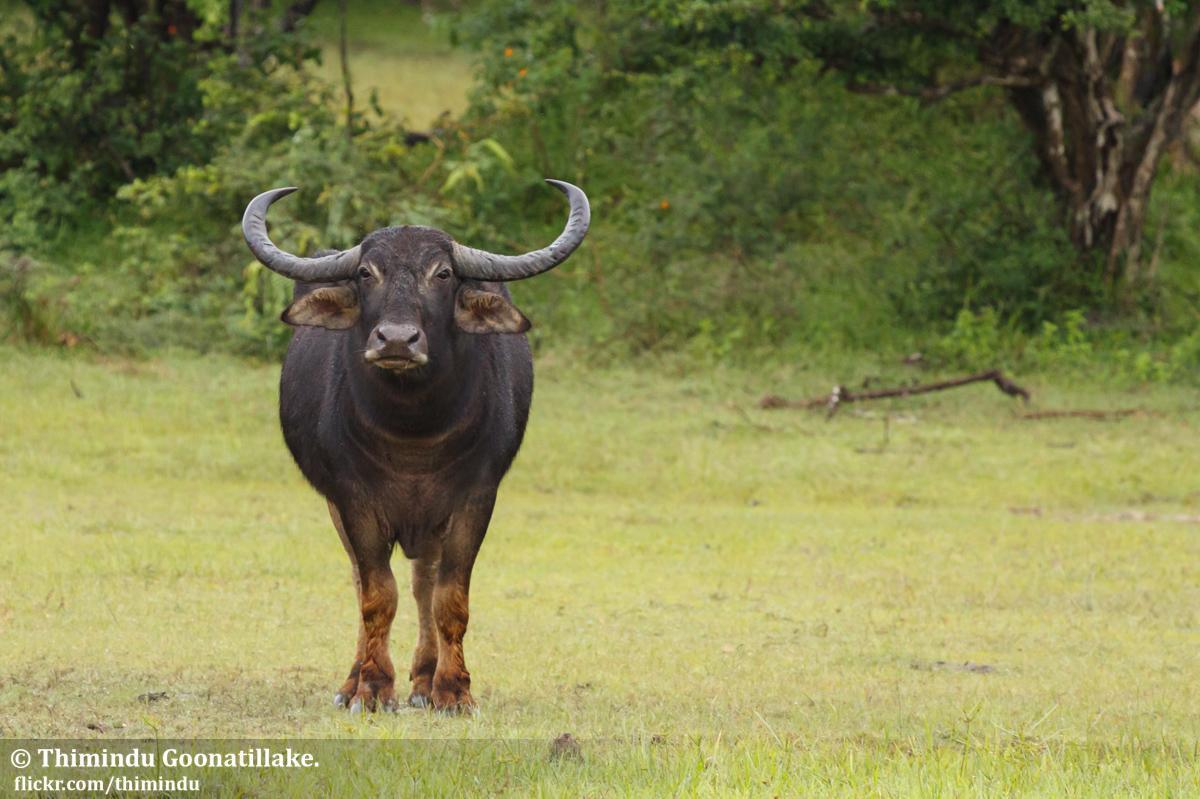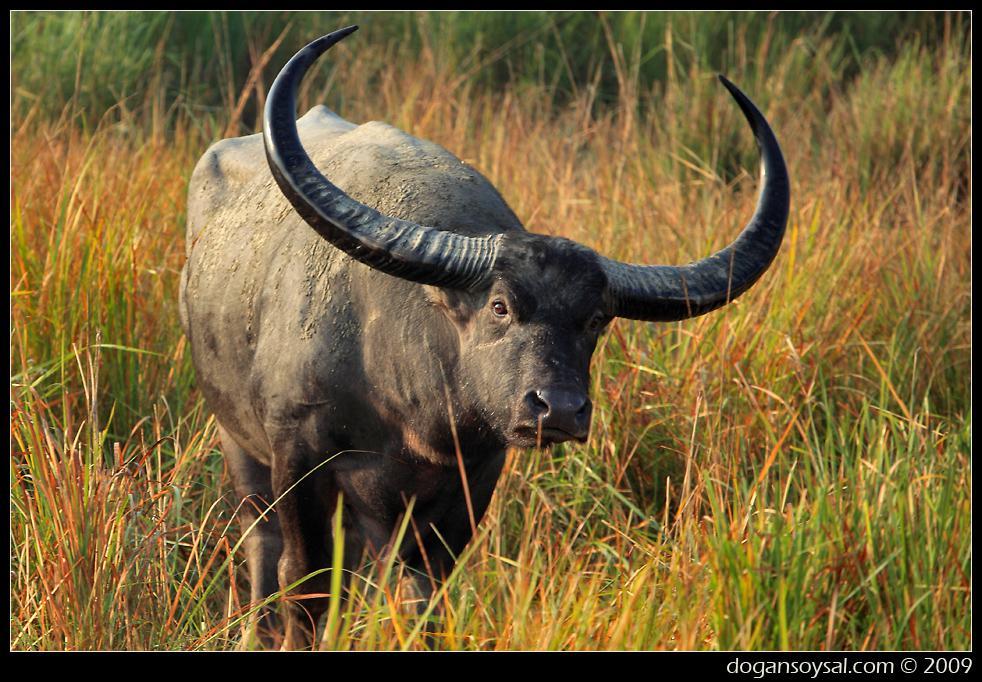The first image is the image on the left, the second image is the image on the right. Considering the images on both sides, is "There is a large black yak in the water." valid? Answer yes or no. No. The first image is the image on the left, the second image is the image on the right. Assess this claim about the two images: "A body of water is visible in the right image of a water buffalo.". Correct or not? Answer yes or no. No. 